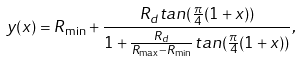Convert formula to latex. <formula><loc_0><loc_0><loc_500><loc_500>y ( x ) = R _ { \min } + \frac { R _ { d } t a n ( \frac { \pi } { 4 } ( 1 + x ) ) } { 1 + \frac { R _ { d } } { R _ { \max } - R _ { \min } } t a n ( \frac { \pi } { 4 } ( 1 + x ) ) } ,</formula> 